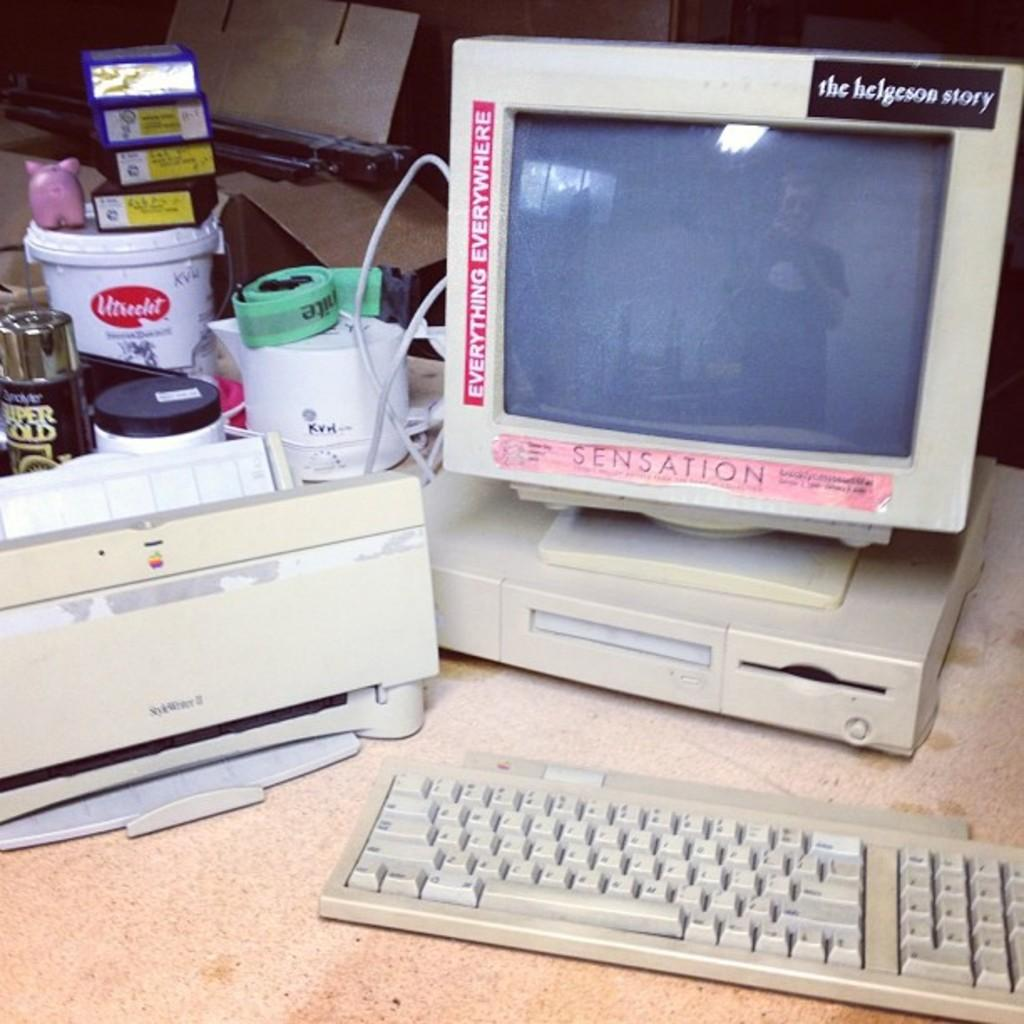<image>
Summarize the visual content of the image. an old computer and monitor with a sensation sticker its border 